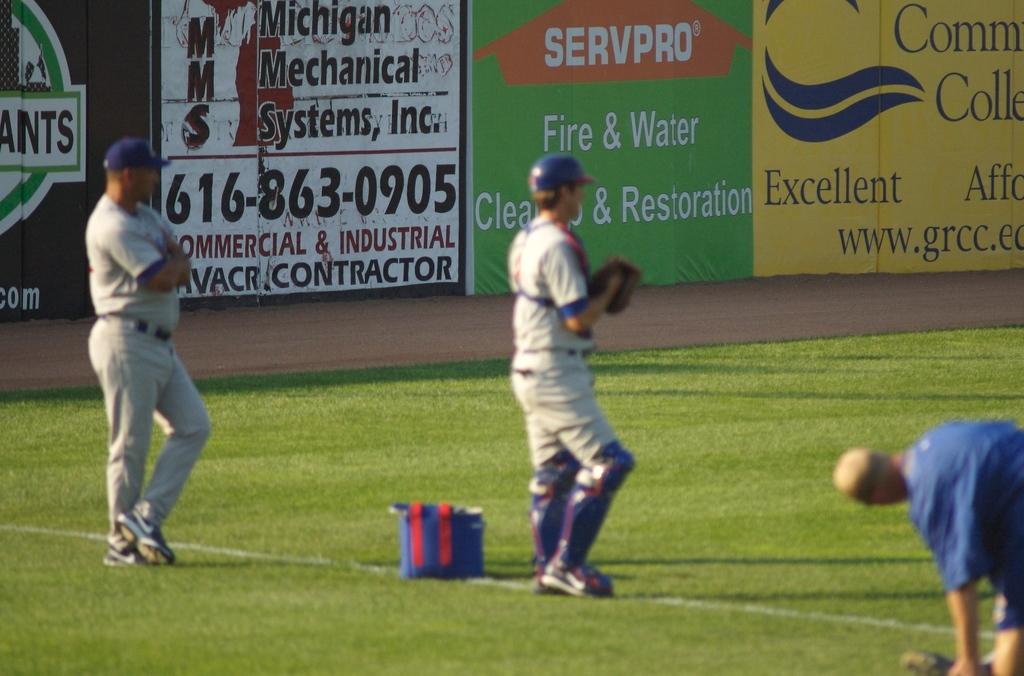Mms does commercial and what else for contracting?
Keep it short and to the point. Industrial. What are they playing?
Your answer should be compact. Baseball. 